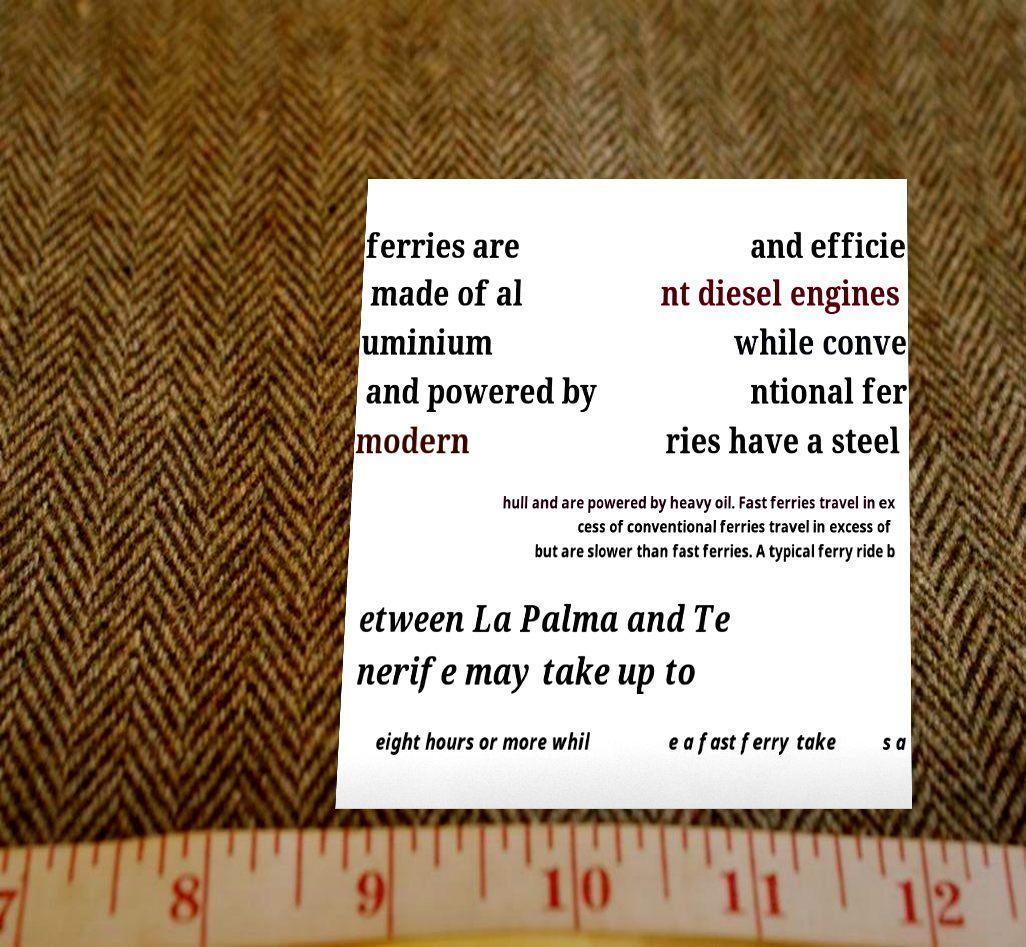Could you extract and type out the text from this image? ferries are made of al uminium and powered by modern and efficie nt diesel engines while conve ntional fer ries have a steel hull and are powered by heavy oil. Fast ferries travel in ex cess of conventional ferries travel in excess of but are slower than fast ferries. A typical ferry ride b etween La Palma and Te nerife may take up to eight hours or more whil e a fast ferry take s a 